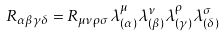Convert formula to latex. <formula><loc_0><loc_0><loc_500><loc_500>R _ { \alpha \beta \gamma \delta } = R _ { \mu \nu \rho \sigma } \lambda ^ { \mu } _ { ( \alpha ) } \lambda ^ { \nu } _ { ( \beta ) } \lambda ^ { \rho } _ { ( \gamma ) } \lambda ^ { \sigma } _ { ( \delta ) }</formula> 